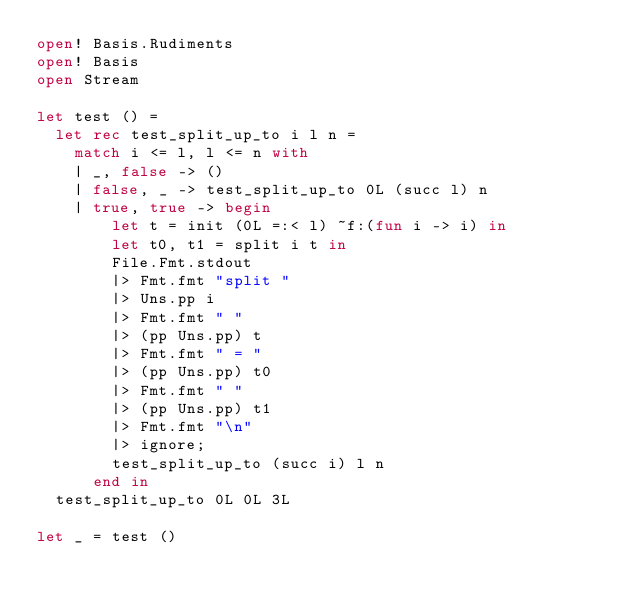Convert code to text. <code><loc_0><loc_0><loc_500><loc_500><_OCaml_>open! Basis.Rudiments
open! Basis
open Stream

let test () =
  let rec test_split_up_to i l n =
    match i <= l, l <= n with
    | _, false -> ()
    | false, _ -> test_split_up_to 0L (succ l) n
    | true, true -> begin
        let t = init (0L =:< l) ~f:(fun i -> i) in
        let t0, t1 = split i t in
        File.Fmt.stdout
        |> Fmt.fmt "split "
        |> Uns.pp i
        |> Fmt.fmt " "
        |> (pp Uns.pp) t
        |> Fmt.fmt " = "
        |> (pp Uns.pp) t0
        |> Fmt.fmt " "
        |> (pp Uns.pp) t1
        |> Fmt.fmt "\n"
        |> ignore;
        test_split_up_to (succ i) l n
      end in
  test_split_up_to 0L 0L 3L

let _ = test ()
</code> 